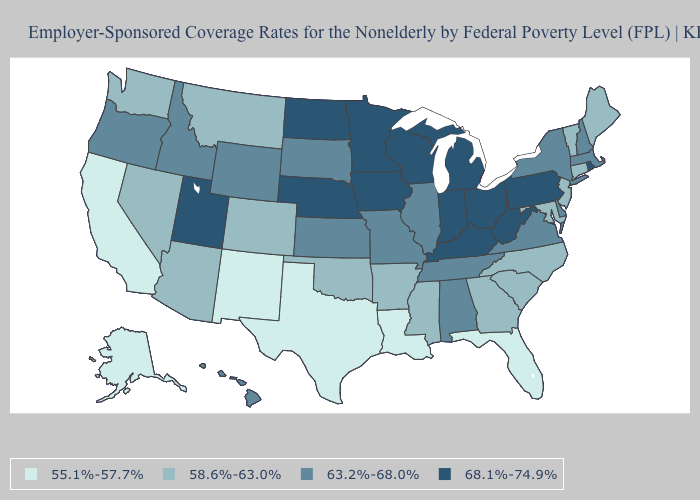Which states have the lowest value in the Northeast?
Quick response, please. Connecticut, Maine, New Jersey, Vermont. Does Indiana have the highest value in the USA?
Write a very short answer. Yes. Among the states that border Colorado , which have the lowest value?
Quick response, please. New Mexico. What is the value of Alabama?
Keep it brief. 63.2%-68.0%. What is the value of Washington?
Concise answer only. 58.6%-63.0%. What is the value of Alaska?
Give a very brief answer. 55.1%-57.7%. What is the value of West Virginia?
Give a very brief answer. 68.1%-74.9%. How many symbols are there in the legend?
Quick response, please. 4. Does Nebraska have a lower value than New Hampshire?
Give a very brief answer. No. How many symbols are there in the legend?
Short answer required. 4. What is the highest value in the West ?
Give a very brief answer. 68.1%-74.9%. Does New York have the lowest value in the Northeast?
Be succinct. No. Which states have the lowest value in the West?
Be succinct. Alaska, California, New Mexico. Name the states that have a value in the range 68.1%-74.9%?
Concise answer only. Indiana, Iowa, Kentucky, Michigan, Minnesota, Nebraska, North Dakota, Ohio, Pennsylvania, Rhode Island, Utah, West Virginia, Wisconsin. What is the value of Maryland?
Be succinct. 58.6%-63.0%. 